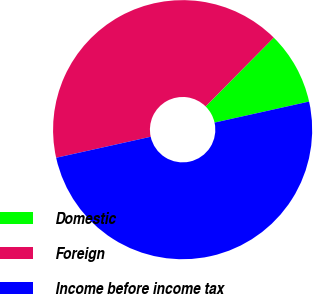Convert chart. <chart><loc_0><loc_0><loc_500><loc_500><pie_chart><fcel>Domestic<fcel>Foreign<fcel>Income before income tax<nl><fcel>9.1%<fcel>40.9%<fcel>50.0%<nl></chart> 